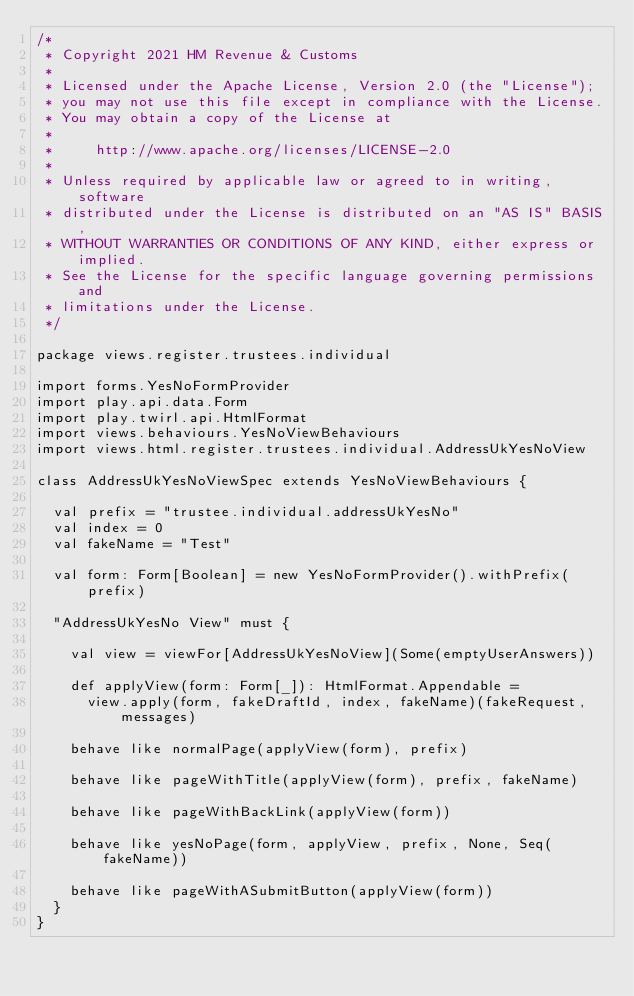Convert code to text. <code><loc_0><loc_0><loc_500><loc_500><_Scala_>/*
 * Copyright 2021 HM Revenue & Customs
 *
 * Licensed under the Apache License, Version 2.0 (the "License");
 * you may not use this file except in compliance with the License.
 * You may obtain a copy of the License at
 *
 *     http://www.apache.org/licenses/LICENSE-2.0
 *
 * Unless required by applicable law or agreed to in writing, software
 * distributed under the License is distributed on an "AS IS" BASIS,
 * WITHOUT WARRANTIES OR CONDITIONS OF ANY KIND, either express or implied.
 * See the License for the specific language governing permissions and
 * limitations under the License.
 */

package views.register.trustees.individual

import forms.YesNoFormProvider
import play.api.data.Form
import play.twirl.api.HtmlFormat
import views.behaviours.YesNoViewBehaviours
import views.html.register.trustees.individual.AddressUkYesNoView

class AddressUkYesNoViewSpec extends YesNoViewBehaviours {

  val prefix = "trustee.individual.addressUkYesNo"
  val index = 0
  val fakeName = "Test"

  val form: Form[Boolean] = new YesNoFormProvider().withPrefix(prefix)

  "AddressUkYesNo View" must {

    val view = viewFor[AddressUkYesNoView](Some(emptyUserAnswers))

    def applyView(form: Form[_]): HtmlFormat.Appendable =
      view.apply(form, fakeDraftId, index, fakeName)(fakeRequest, messages)

    behave like normalPage(applyView(form), prefix)

    behave like pageWithTitle(applyView(form), prefix, fakeName)

    behave like pageWithBackLink(applyView(form))

    behave like yesNoPage(form, applyView, prefix, None, Seq(fakeName))

    behave like pageWithASubmitButton(applyView(form))
  }
}
</code> 